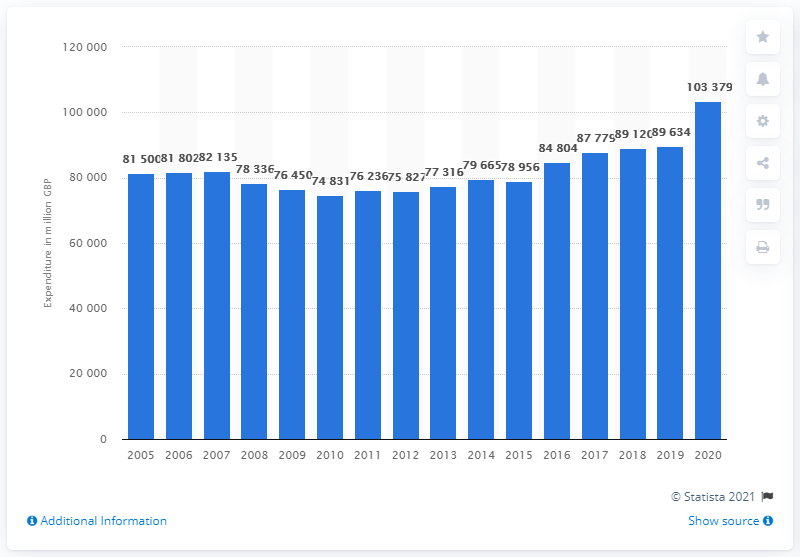Indicate a few pertinent items in this graphic. In 2019, households in the UK purchased approximately 103,379 pounds worth of food. Food purchases in the UK have been increasing since 2015. 